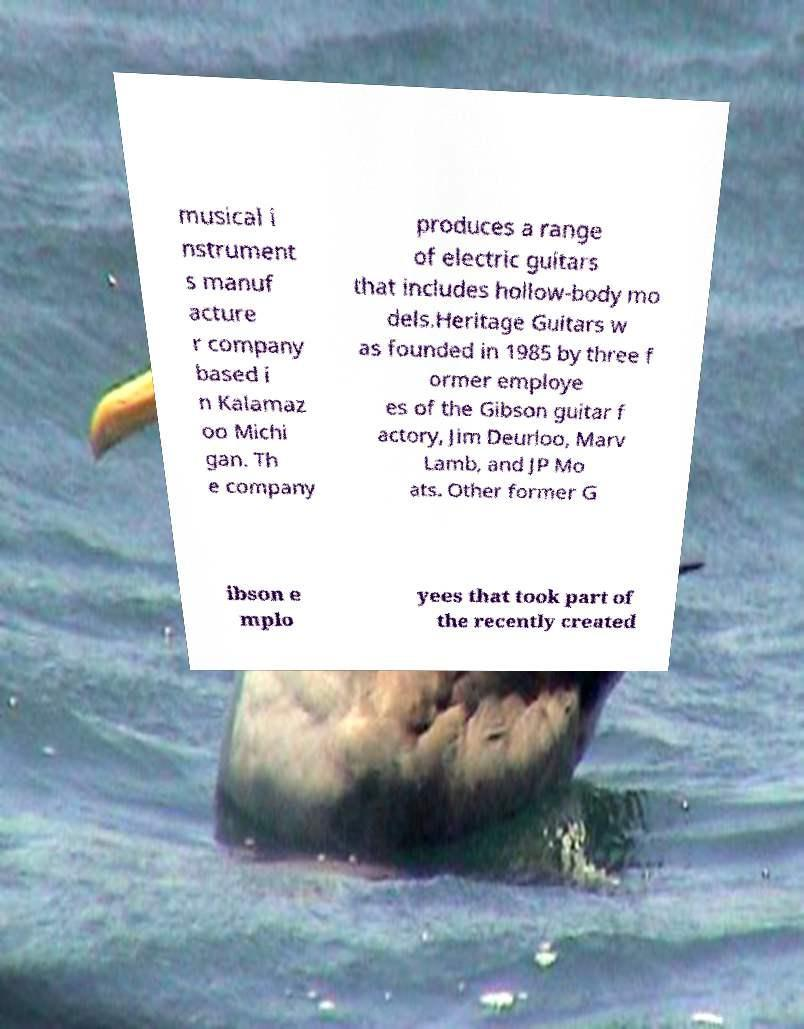For documentation purposes, I need the text within this image transcribed. Could you provide that? musical i nstrument s manuf acture r company based i n Kalamaz oo Michi gan. Th e company produces a range of electric guitars that includes hollow-body mo dels.Heritage Guitars w as founded in 1985 by three f ormer employe es of the Gibson guitar f actory, Jim Deurloo, Marv Lamb, and JP Mo ats. Other former G ibson e mplo yees that took part of the recently created 